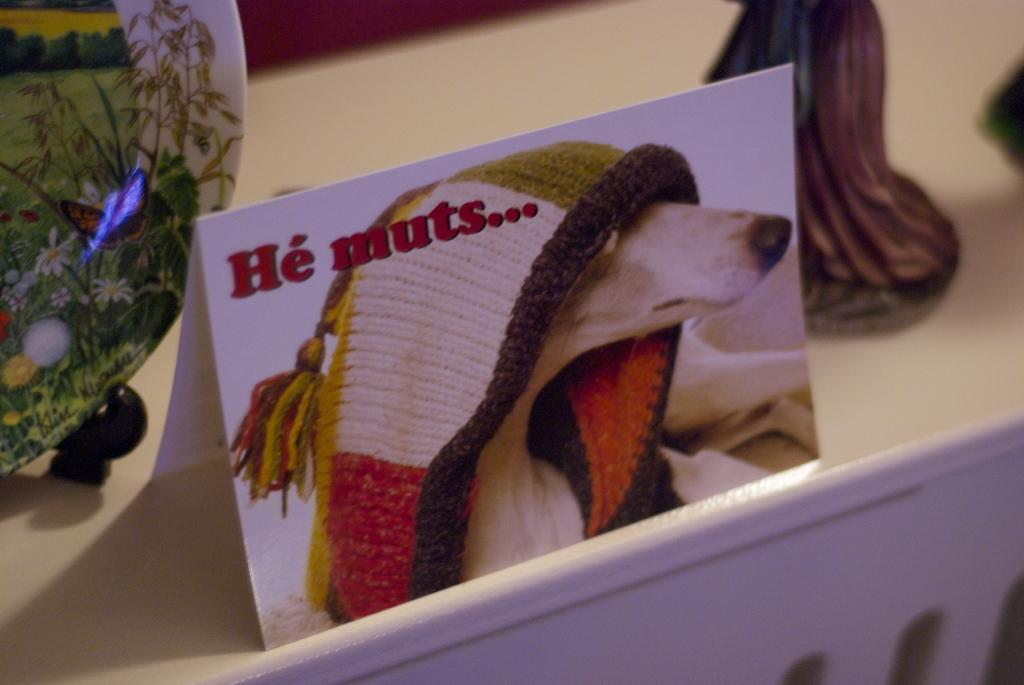What is the main object in the image? There is a board in the image. What is on the board? There is an animal with a cloth on the board. What else can be seen in the image besides the board and animal? There are decorative objects visible in the image. What color is the surface on which the board and decorative objects are placed? The surface is cream-colored. What type of oven is being used to cook the animal on the board? There is no oven present in the image, and the animal is not being cooked. 